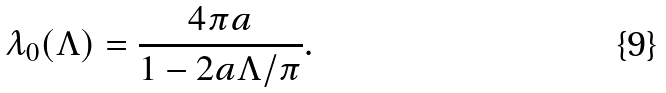<formula> <loc_0><loc_0><loc_500><loc_500>\lambda _ { 0 } ( \Lambda ) = \frac { 4 \pi a } { 1 - 2 a \Lambda / \pi } .</formula> 